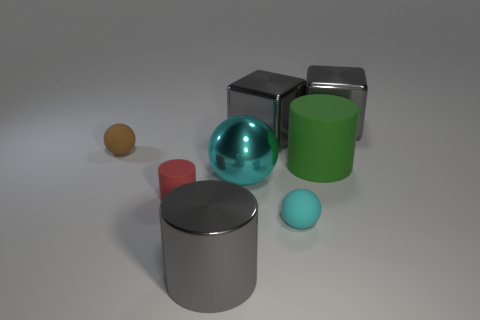What number of things are big blue matte objects or big cylinders left of the large green cylinder?
Your answer should be compact. 1. What material is the tiny thing that is the same color as the large metallic ball?
Keep it short and to the point. Rubber. Is the size of the gray object in front of the cyan metal ball the same as the large cyan shiny ball?
Your response must be concise. Yes. There is a metal block to the right of the cylinder behind the small red matte object; how many small things are behind it?
Give a very brief answer. 0. How many cyan objects are either metal spheres or small metallic balls?
Make the answer very short. 1. What is the color of the large object that is made of the same material as the small brown object?
Your answer should be very brief. Green. Is there anything else that is the same size as the cyan rubber thing?
Offer a terse response. Yes. What number of tiny things are either red rubber blocks or metallic cubes?
Offer a very short reply. 0. Is the number of big green objects less than the number of small matte spheres?
Make the answer very short. Yes. There is another large metallic object that is the same shape as the red thing; what is its color?
Provide a succinct answer. Gray. 